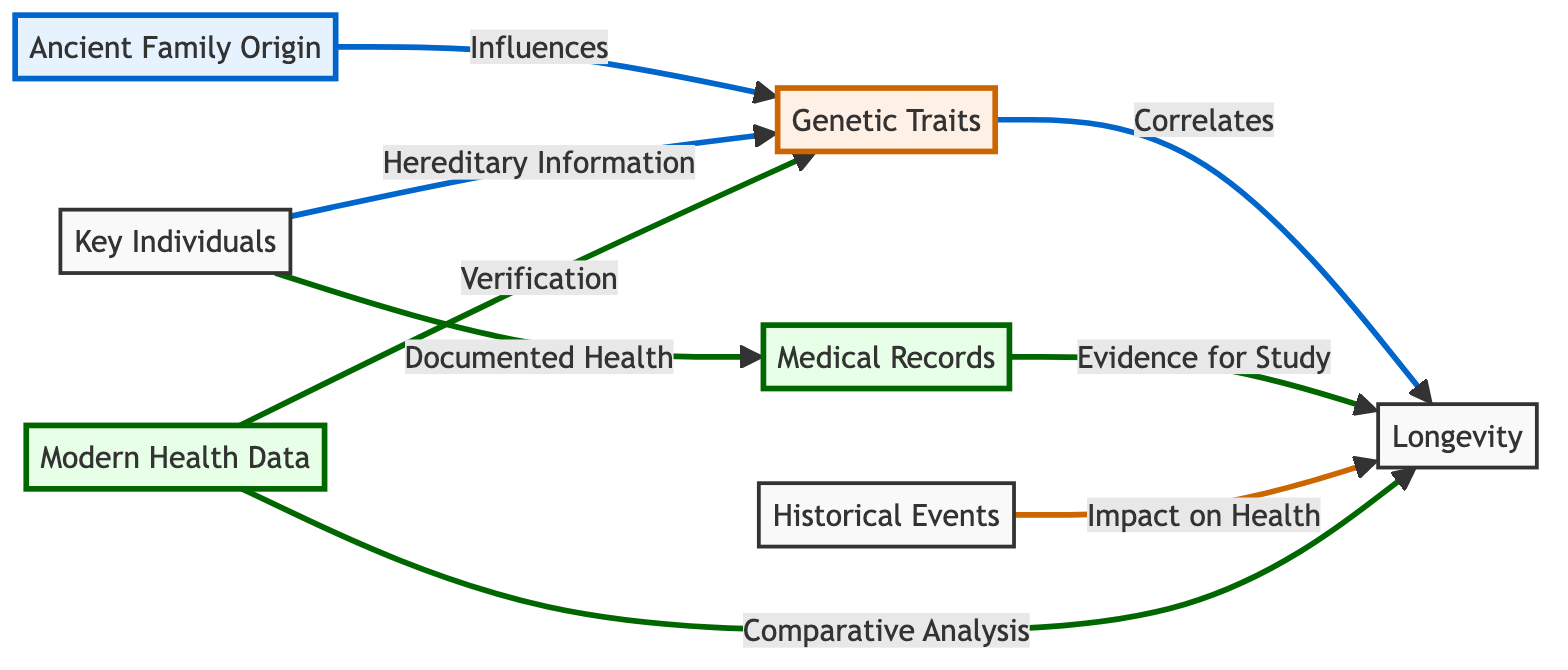What is the primary influence on Genetic Traits? The diagram indicates that the Ancient Family Origin is the primary influence on Genetic Traits as shown by the arrow connecting AFO to GT.
Answer: Ancient Family Origin Which node correlates with Longevity? The Genetic Traits node directly correlates with Longevity, as shown by the arrow connecting GT to L.
Answer: Genetic Traits How many types of data are represented in the diagram? The diagram features three types of data nodes: Medical Records, Modern Health Data, and Genetic Traits, totaling three data nodes.
Answer: Three What is the role of Key Individuals in the diagram? Key Individuals provide hereditary information to Genetic Traits and also documented health to Medical Records, as indicated by the arrows from KI to both GT and MR.
Answer: Hereditary Information What does Modern Health Data verify? Modern Health Data is specified in the diagram to verify Genetic Traits, shown by the arrow connecting MHD to GT.
Answer: Genetic Traits What impact do Historical Events have on Longevity? Historical Events influence Longevity directly in the diagram, as depicted by the arrow leading from HE to L.
Answer: Impact on Health Which nodes are linked by evidence for study? The Medical Records node provides evidence for the study of Longevity, indicated by the connecting arrow between MR and L.
Answer: Medical Records How does Longevity relate to Modern Health Data? The diagram shows that Modern Health Data allows for a comparative analysis of Longevity, indicated by the arrow coming from MHD to L.
Answer: Comparative Analysis What color is used for Genetic Traits in the diagram? The Genetic Traits node is represented in orange, as indicated by the fill color specified for the trait class.
Answer: Orange 